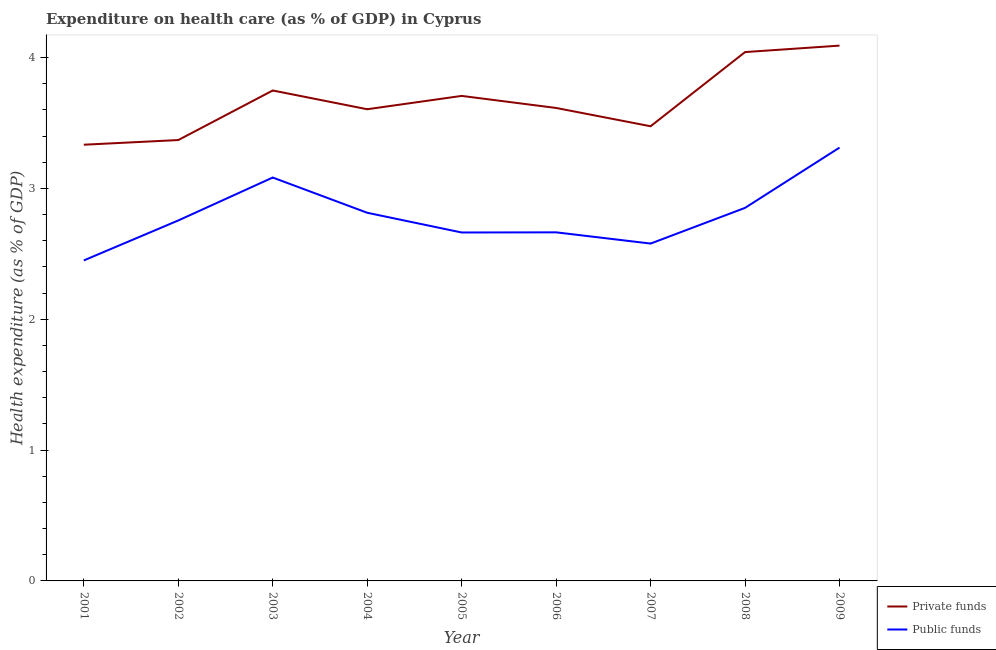Does the line corresponding to amount of public funds spent in healthcare intersect with the line corresponding to amount of private funds spent in healthcare?
Offer a terse response. No. Is the number of lines equal to the number of legend labels?
Your answer should be compact. Yes. What is the amount of private funds spent in healthcare in 2006?
Give a very brief answer. 3.61. Across all years, what is the maximum amount of private funds spent in healthcare?
Provide a short and direct response. 4.09. Across all years, what is the minimum amount of public funds spent in healthcare?
Offer a terse response. 2.45. What is the total amount of private funds spent in healthcare in the graph?
Ensure brevity in your answer.  32.98. What is the difference between the amount of private funds spent in healthcare in 2004 and that in 2006?
Your answer should be very brief. -0.01. What is the difference between the amount of private funds spent in healthcare in 2002 and the amount of public funds spent in healthcare in 2006?
Keep it short and to the point. 0.71. What is the average amount of private funds spent in healthcare per year?
Your answer should be compact. 3.66. In the year 2006, what is the difference between the amount of private funds spent in healthcare and amount of public funds spent in healthcare?
Offer a terse response. 0.95. In how many years, is the amount of public funds spent in healthcare greater than 3.2 %?
Your answer should be compact. 1. What is the ratio of the amount of public funds spent in healthcare in 2005 to that in 2009?
Keep it short and to the point. 0.8. Is the amount of private funds spent in healthcare in 2004 less than that in 2009?
Make the answer very short. Yes. What is the difference between the highest and the second highest amount of private funds spent in healthcare?
Your answer should be very brief. 0.05. What is the difference between the highest and the lowest amount of public funds spent in healthcare?
Your answer should be compact. 0.86. In how many years, is the amount of public funds spent in healthcare greater than the average amount of public funds spent in healthcare taken over all years?
Keep it short and to the point. 4. Is the sum of the amount of private funds spent in healthcare in 2001 and 2006 greater than the maximum amount of public funds spent in healthcare across all years?
Offer a terse response. Yes. Does the amount of public funds spent in healthcare monotonically increase over the years?
Give a very brief answer. No. Is the amount of public funds spent in healthcare strictly less than the amount of private funds spent in healthcare over the years?
Provide a short and direct response. Yes. What is the title of the graph?
Make the answer very short. Expenditure on health care (as % of GDP) in Cyprus. What is the label or title of the X-axis?
Provide a short and direct response. Year. What is the label or title of the Y-axis?
Make the answer very short. Health expenditure (as % of GDP). What is the Health expenditure (as % of GDP) of Private funds in 2001?
Your answer should be compact. 3.33. What is the Health expenditure (as % of GDP) in Public funds in 2001?
Provide a succinct answer. 2.45. What is the Health expenditure (as % of GDP) of Private funds in 2002?
Provide a short and direct response. 3.37. What is the Health expenditure (as % of GDP) in Public funds in 2002?
Make the answer very short. 2.75. What is the Health expenditure (as % of GDP) of Private funds in 2003?
Offer a very short reply. 3.75. What is the Health expenditure (as % of GDP) of Public funds in 2003?
Provide a short and direct response. 3.08. What is the Health expenditure (as % of GDP) in Private funds in 2004?
Your answer should be very brief. 3.6. What is the Health expenditure (as % of GDP) in Public funds in 2004?
Offer a very short reply. 2.81. What is the Health expenditure (as % of GDP) in Private funds in 2005?
Keep it short and to the point. 3.71. What is the Health expenditure (as % of GDP) of Public funds in 2005?
Your response must be concise. 2.66. What is the Health expenditure (as % of GDP) of Private funds in 2006?
Provide a short and direct response. 3.61. What is the Health expenditure (as % of GDP) in Public funds in 2006?
Your answer should be compact. 2.66. What is the Health expenditure (as % of GDP) in Private funds in 2007?
Give a very brief answer. 3.47. What is the Health expenditure (as % of GDP) of Public funds in 2007?
Ensure brevity in your answer.  2.58. What is the Health expenditure (as % of GDP) of Private funds in 2008?
Provide a succinct answer. 4.04. What is the Health expenditure (as % of GDP) in Public funds in 2008?
Offer a very short reply. 2.85. What is the Health expenditure (as % of GDP) of Private funds in 2009?
Your answer should be compact. 4.09. What is the Health expenditure (as % of GDP) in Public funds in 2009?
Offer a terse response. 3.31. Across all years, what is the maximum Health expenditure (as % of GDP) of Private funds?
Your answer should be compact. 4.09. Across all years, what is the maximum Health expenditure (as % of GDP) of Public funds?
Your response must be concise. 3.31. Across all years, what is the minimum Health expenditure (as % of GDP) in Private funds?
Provide a succinct answer. 3.33. Across all years, what is the minimum Health expenditure (as % of GDP) in Public funds?
Offer a very short reply. 2.45. What is the total Health expenditure (as % of GDP) in Private funds in the graph?
Ensure brevity in your answer.  32.98. What is the total Health expenditure (as % of GDP) of Public funds in the graph?
Provide a short and direct response. 25.17. What is the difference between the Health expenditure (as % of GDP) of Private funds in 2001 and that in 2002?
Your answer should be compact. -0.04. What is the difference between the Health expenditure (as % of GDP) in Public funds in 2001 and that in 2002?
Give a very brief answer. -0.31. What is the difference between the Health expenditure (as % of GDP) in Private funds in 2001 and that in 2003?
Provide a succinct answer. -0.41. What is the difference between the Health expenditure (as % of GDP) in Public funds in 2001 and that in 2003?
Offer a very short reply. -0.63. What is the difference between the Health expenditure (as % of GDP) in Private funds in 2001 and that in 2004?
Your answer should be compact. -0.27. What is the difference between the Health expenditure (as % of GDP) of Public funds in 2001 and that in 2004?
Offer a terse response. -0.36. What is the difference between the Health expenditure (as % of GDP) in Private funds in 2001 and that in 2005?
Provide a succinct answer. -0.37. What is the difference between the Health expenditure (as % of GDP) in Public funds in 2001 and that in 2005?
Ensure brevity in your answer.  -0.21. What is the difference between the Health expenditure (as % of GDP) of Private funds in 2001 and that in 2006?
Provide a succinct answer. -0.28. What is the difference between the Health expenditure (as % of GDP) of Public funds in 2001 and that in 2006?
Provide a succinct answer. -0.21. What is the difference between the Health expenditure (as % of GDP) in Private funds in 2001 and that in 2007?
Offer a very short reply. -0.14. What is the difference between the Health expenditure (as % of GDP) in Public funds in 2001 and that in 2007?
Ensure brevity in your answer.  -0.13. What is the difference between the Health expenditure (as % of GDP) in Private funds in 2001 and that in 2008?
Give a very brief answer. -0.71. What is the difference between the Health expenditure (as % of GDP) in Public funds in 2001 and that in 2008?
Give a very brief answer. -0.4. What is the difference between the Health expenditure (as % of GDP) of Private funds in 2001 and that in 2009?
Offer a very short reply. -0.76. What is the difference between the Health expenditure (as % of GDP) in Public funds in 2001 and that in 2009?
Your answer should be very brief. -0.86. What is the difference between the Health expenditure (as % of GDP) of Private funds in 2002 and that in 2003?
Provide a short and direct response. -0.38. What is the difference between the Health expenditure (as % of GDP) of Public funds in 2002 and that in 2003?
Your answer should be compact. -0.33. What is the difference between the Health expenditure (as % of GDP) of Private funds in 2002 and that in 2004?
Your answer should be compact. -0.24. What is the difference between the Health expenditure (as % of GDP) of Public funds in 2002 and that in 2004?
Provide a succinct answer. -0.06. What is the difference between the Health expenditure (as % of GDP) in Private funds in 2002 and that in 2005?
Make the answer very short. -0.34. What is the difference between the Health expenditure (as % of GDP) of Public funds in 2002 and that in 2005?
Your response must be concise. 0.09. What is the difference between the Health expenditure (as % of GDP) in Private funds in 2002 and that in 2006?
Offer a terse response. -0.25. What is the difference between the Health expenditure (as % of GDP) of Public funds in 2002 and that in 2006?
Keep it short and to the point. 0.09. What is the difference between the Health expenditure (as % of GDP) in Private funds in 2002 and that in 2007?
Your answer should be very brief. -0.11. What is the difference between the Health expenditure (as % of GDP) in Public funds in 2002 and that in 2007?
Keep it short and to the point. 0.18. What is the difference between the Health expenditure (as % of GDP) of Private funds in 2002 and that in 2008?
Your response must be concise. -0.67. What is the difference between the Health expenditure (as % of GDP) of Public funds in 2002 and that in 2008?
Keep it short and to the point. -0.1. What is the difference between the Health expenditure (as % of GDP) of Private funds in 2002 and that in 2009?
Provide a short and direct response. -0.72. What is the difference between the Health expenditure (as % of GDP) in Public funds in 2002 and that in 2009?
Make the answer very short. -0.56. What is the difference between the Health expenditure (as % of GDP) in Private funds in 2003 and that in 2004?
Offer a terse response. 0.14. What is the difference between the Health expenditure (as % of GDP) in Public funds in 2003 and that in 2004?
Offer a terse response. 0.27. What is the difference between the Health expenditure (as % of GDP) in Private funds in 2003 and that in 2005?
Provide a short and direct response. 0.04. What is the difference between the Health expenditure (as % of GDP) in Public funds in 2003 and that in 2005?
Provide a short and direct response. 0.42. What is the difference between the Health expenditure (as % of GDP) of Private funds in 2003 and that in 2006?
Provide a succinct answer. 0.13. What is the difference between the Health expenditure (as % of GDP) of Public funds in 2003 and that in 2006?
Give a very brief answer. 0.42. What is the difference between the Health expenditure (as % of GDP) of Private funds in 2003 and that in 2007?
Offer a terse response. 0.27. What is the difference between the Health expenditure (as % of GDP) of Public funds in 2003 and that in 2007?
Make the answer very short. 0.5. What is the difference between the Health expenditure (as % of GDP) in Private funds in 2003 and that in 2008?
Provide a succinct answer. -0.29. What is the difference between the Health expenditure (as % of GDP) of Public funds in 2003 and that in 2008?
Your answer should be very brief. 0.23. What is the difference between the Health expenditure (as % of GDP) in Private funds in 2003 and that in 2009?
Your answer should be compact. -0.34. What is the difference between the Health expenditure (as % of GDP) in Public funds in 2003 and that in 2009?
Offer a terse response. -0.23. What is the difference between the Health expenditure (as % of GDP) in Private funds in 2004 and that in 2005?
Make the answer very short. -0.1. What is the difference between the Health expenditure (as % of GDP) of Public funds in 2004 and that in 2005?
Keep it short and to the point. 0.15. What is the difference between the Health expenditure (as % of GDP) of Private funds in 2004 and that in 2006?
Keep it short and to the point. -0.01. What is the difference between the Health expenditure (as % of GDP) of Public funds in 2004 and that in 2006?
Ensure brevity in your answer.  0.15. What is the difference between the Health expenditure (as % of GDP) of Private funds in 2004 and that in 2007?
Provide a succinct answer. 0.13. What is the difference between the Health expenditure (as % of GDP) of Public funds in 2004 and that in 2007?
Provide a short and direct response. 0.24. What is the difference between the Health expenditure (as % of GDP) in Private funds in 2004 and that in 2008?
Offer a terse response. -0.44. What is the difference between the Health expenditure (as % of GDP) in Public funds in 2004 and that in 2008?
Provide a succinct answer. -0.04. What is the difference between the Health expenditure (as % of GDP) in Private funds in 2004 and that in 2009?
Make the answer very short. -0.49. What is the difference between the Health expenditure (as % of GDP) of Public funds in 2004 and that in 2009?
Offer a terse response. -0.5. What is the difference between the Health expenditure (as % of GDP) in Private funds in 2005 and that in 2006?
Your response must be concise. 0.09. What is the difference between the Health expenditure (as % of GDP) of Public funds in 2005 and that in 2006?
Provide a succinct answer. -0. What is the difference between the Health expenditure (as % of GDP) in Private funds in 2005 and that in 2007?
Ensure brevity in your answer.  0.23. What is the difference between the Health expenditure (as % of GDP) in Public funds in 2005 and that in 2007?
Your response must be concise. 0.08. What is the difference between the Health expenditure (as % of GDP) of Private funds in 2005 and that in 2008?
Your answer should be compact. -0.33. What is the difference between the Health expenditure (as % of GDP) of Public funds in 2005 and that in 2008?
Offer a very short reply. -0.19. What is the difference between the Health expenditure (as % of GDP) in Private funds in 2005 and that in 2009?
Offer a terse response. -0.38. What is the difference between the Health expenditure (as % of GDP) of Public funds in 2005 and that in 2009?
Provide a succinct answer. -0.65. What is the difference between the Health expenditure (as % of GDP) in Private funds in 2006 and that in 2007?
Your answer should be compact. 0.14. What is the difference between the Health expenditure (as % of GDP) in Public funds in 2006 and that in 2007?
Give a very brief answer. 0.09. What is the difference between the Health expenditure (as % of GDP) in Private funds in 2006 and that in 2008?
Provide a short and direct response. -0.43. What is the difference between the Health expenditure (as % of GDP) of Public funds in 2006 and that in 2008?
Ensure brevity in your answer.  -0.19. What is the difference between the Health expenditure (as % of GDP) of Private funds in 2006 and that in 2009?
Your response must be concise. -0.48. What is the difference between the Health expenditure (as % of GDP) in Public funds in 2006 and that in 2009?
Give a very brief answer. -0.65. What is the difference between the Health expenditure (as % of GDP) of Private funds in 2007 and that in 2008?
Provide a short and direct response. -0.57. What is the difference between the Health expenditure (as % of GDP) in Public funds in 2007 and that in 2008?
Your answer should be very brief. -0.27. What is the difference between the Health expenditure (as % of GDP) in Private funds in 2007 and that in 2009?
Keep it short and to the point. -0.62. What is the difference between the Health expenditure (as % of GDP) in Public funds in 2007 and that in 2009?
Keep it short and to the point. -0.73. What is the difference between the Health expenditure (as % of GDP) of Private funds in 2008 and that in 2009?
Make the answer very short. -0.05. What is the difference between the Health expenditure (as % of GDP) in Public funds in 2008 and that in 2009?
Ensure brevity in your answer.  -0.46. What is the difference between the Health expenditure (as % of GDP) in Private funds in 2001 and the Health expenditure (as % of GDP) in Public funds in 2002?
Make the answer very short. 0.58. What is the difference between the Health expenditure (as % of GDP) of Private funds in 2001 and the Health expenditure (as % of GDP) of Public funds in 2003?
Ensure brevity in your answer.  0.25. What is the difference between the Health expenditure (as % of GDP) of Private funds in 2001 and the Health expenditure (as % of GDP) of Public funds in 2004?
Give a very brief answer. 0.52. What is the difference between the Health expenditure (as % of GDP) in Private funds in 2001 and the Health expenditure (as % of GDP) in Public funds in 2005?
Your response must be concise. 0.67. What is the difference between the Health expenditure (as % of GDP) of Private funds in 2001 and the Health expenditure (as % of GDP) of Public funds in 2006?
Offer a terse response. 0.67. What is the difference between the Health expenditure (as % of GDP) of Private funds in 2001 and the Health expenditure (as % of GDP) of Public funds in 2007?
Provide a succinct answer. 0.76. What is the difference between the Health expenditure (as % of GDP) of Private funds in 2001 and the Health expenditure (as % of GDP) of Public funds in 2008?
Your answer should be very brief. 0.48. What is the difference between the Health expenditure (as % of GDP) in Private funds in 2001 and the Health expenditure (as % of GDP) in Public funds in 2009?
Provide a short and direct response. 0.02. What is the difference between the Health expenditure (as % of GDP) in Private funds in 2002 and the Health expenditure (as % of GDP) in Public funds in 2003?
Ensure brevity in your answer.  0.29. What is the difference between the Health expenditure (as % of GDP) in Private funds in 2002 and the Health expenditure (as % of GDP) in Public funds in 2004?
Give a very brief answer. 0.56. What is the difference between the Health expenditure (as % of GDP) in Private funds in 2002 and the Health expenditure (as % of GDP) in Public funds in 2005?
Keep it short and to the point. 0.71. What is the difference between the Health expenditure (as % of GDP) of Private funds in 2002 and the Health expenditure (as % of GDP) of Public funds in 2006?
Your response must be concise. 0.71. What is the difference between the Health expenditure (as % of GDP) in Private funds in 2002 and the Health expenditure (as % of GDP) in Public funds in 2007?
Make the answer very short. 0.79. What is the difference between the Health expenditure (as % of GDP) in Private funds in 2002 and the Health expenditure (as % of GDP) in Public funds in 2008?
Your answer should be compact. 0.52. What is the difference between the Health expenditure (as % of GDP) in Private funds in 2002 and the Health expenditure (as % of GDP) in Public funds in 2009?
Ensure brevity in your answer.  0.06. What is the difference between the Health expenditure (as % of GDP) in Private funds in 2003 and the Health expenditure (as % of GDP) in Public funds in 2004?
Offer a very short reply. 0.93. What is the difference between the Health expenditure (as % of GDP) in Private funds in 2003 and the Health expenditure (as % of GDP) in Public funds in 2005?
Keep it short and to the point. 1.09. What is the difference between the Health expenditure (as % of GDP) in Private funds in 2003 and the Health expenditure (as % of GDP) in Public funds in 2006?
Make the answer very short. 1.08. What is the difference between the Health expenditure (as % of GDP) of Private funds in 2003 and the Health expenditure (as % of GDP) of Public funds in 2007?
Your answer should be compact. 1.17. What is the difference between the Health expenditure (as % of GDP) in Private funds in 2003 and the Health expenditure (as % of GDP) in Public funds in 2008?
Give a very brief answer. 0.9. What is the difference between the Health expenditure (as % of GDP) of Private funds in 2003 and the Health expenditure (as % of GDP) of Public funds in 2009?
Your response must be concise. 0.44. What is the difference between the Health expenditure (as % of GDP) in Private funds in 2004 and the Health expenditure (as % of GDP) in Public funds in 2005?
Offer a very short reply. 0.94. What is the difference between the Health expenditure (as % of GDP) of Private funds in 2004 and the Health expenditure (as % of GDP) of Public funds in 2006?
Keep it short and to the point. 0.94. What is the difference between the Health expenditure (as % of GDP) of Private funds in 2004 and the Health expenditure (as % of GDP) of Public funds in 2007?
Your response must be concise. 1.03. What is the difference between the Health expenditure (as % of GDP) in Private funds in 2004 and the Health expenditure (as % of GDP) in Public funds in 2008?
Your answer should be very brief. 0.75. What is the difference between the Health expenditure (as % of GDP) of Private funds in 2004 and the Health expenditure (as % of GDP) of Public funds in 2009?
Provide a short and direct response. 0.29. What is the difference between the Health expenditure (as % of GDP) of Private funds in 2005 and the Health expenditure (as % of GDP) of Public funds in 2006?
Your answer should be compact. 1.04. What is the difference between the Health expenditure (as % of GDP) in Private funds in 2005 and the Health expenditure (as % of GDP) in Public funds in 2007?
Make the answer very short. 1.13. What is the difference between the Health expenditure (as % of GDP) in Private funds in 2005 and the Health expenditure (as % of GDP) in Public funds in 2008?
Make the answer very short. 0.86. What is the difference between the Health expenditure (as % of GDP) in Private funds in 2005 and the Health expenditure (as % of GDP) in Public funds in 2009?
Give a very brief answer. 0.39. What is the difference between the Health expenditure (as % of GDP) in Private funds in 2006 and the Health expenditure (as % of GDP) in Public funds in 2007?
Provide a short and direct response. 1.04. What is the difference between the Health expenditure (as % of GDP) in Private funds in 2006 and the Health expenditure (as % of GDP) in Public funds in 2008?
Your answer should be very brief. 0.76. What is the difference between the Health expenditure (as % of GDP) of Private funds in 2006 and the Health expenditure (as % of GDP) of Public funds in 2009?
Ensure brevity in your answer.  0.3. What is the difference between the Health expenditure (as % of GDP) in Private funds in 2007 and the Health expenditure (as % of GDP) in Public funds in 2008?
Keep it short and to the point. 0.62. What is the difference between the Health expenditure (as % of GDP) of Private funds in 2007 and the Health expenditure (as % of GDP) of Public funds in 2009?
Give a very brief answer. 0.16. What is the difference between the Health expenditure (as % of GDP) in Private funds in 2008 and the Health expenditure (as % of GDP) in Public funds in 2009?
Keep it short and to the point. 0.73. What is the average Health expenditure (as % of GDP) in Private funds per year?
Offer a very short reply. 3.66. What is the average Health expenditure (as % of GDP) of Public funds per year?
Your response must be concise. 2.8. In the year 2001, what is the difference between the Health expenditure (as % of GDP) in Private funds and Health expenditure (as % of GDP) in Public funds?
Ensure brevity in your answer.  0.88. In the year 2002, what is the difference between the Health expenditure (as % of GDP) in Private funds and Health expenditure (as % of GDP) in Public funds?
Give a very brief answer. 0.61. In the year 2003, what is the difference between the Health expenditure (as % of GDP) of Private funds and Health expenditure (as % of GDP) of Public funds?
Keep it short and to the point. 0.67. In the year 2004, what is the difference between the Health expenditure (as % of GDP) in Private funds and Health expenditure (as % of GDP) in Public funds?
Provide a succinct answer. 0.79. In the year 2005, what is the difference between the Health expenditure (as % of GDP) of Private funds and Health expenditure (as % of GDP) of Public funds?
Offer a terse response. 1.04. In the year 2006, what is the difference between the Health expenditure (as % of GDP) of Private funds and Health expenditure (as % of GDP) of Public funds?
Make the answer very short. 0.95. In the year 2007, what is the difference between the Health expenditure (as % of GDP) of Private funds and Health expenditure (as % of GDP) of Public funds?
Keep it short and to the point. 0.9. In the year 2008, what is the difference between the Health expenditure (as % of GDP) in Private funds and Health expenditure (as % of GDP) in Public funds?
Provide a succinct answer. 1.19. In the year 2009, what is the difference between the Health expenditure (as % of GDP) in Private funds and Health expenditure (as % of GDP) in Public funds?
Offer a terse response. 0.78. What is the ratio of the Health expenditure (as % of GDP) of Public funds in 2001 to that in 2002?
Offer a very short reply. 0.89. What is the ratio of the Health expenditure (as % of GDP) in Private funds in 2001 to that in 2003?
Your response must be concise. 0.89. What is the ratio of the Health expenditure (as % of GDP) in Public funds in 2001 to that in 2003?
Give a very brief answer. 0.79. What is the ratio of the Health expenditure (as % of GDP) of Private funds in 2001 to that in 2004?
Offer a terse response. 0.92. What is the ratio of the Health expenditure (as % of GDP) in Public funds in 2001 to that in 2004?
Your answer should be very brief. 0.87. What is the ratio of the Health expenditure (as % of GDP) of Private funds in 2001 to that in 2005?
Make the answer very short. 0.9. What is the ratio of the Health expenditure (as % of GDP) of Public funds in 2001 to that in 2005?
Your response must be concise. 0.92. What is the ratio of the Health expenditure (as % of GDP) of Private funds in 2001 to that in 2006?
Your answer should be compact. 0.92. What is the ratio of the Health expenditure (as % of GDP) in Public funds in 2001 to that in 2006?
Your answer should be compact. 0.92. What is the ratio of the Health expenditure (as % of GDP) in Private funds in 2001 to that in 2007?
Keep it short and to the point. 0.96. What is the ratio of the Health expenditure (as % of GDP) in Private funds in 2001 to that in 2008?
Your response must be concise. 0.82. What is the ratio of the Health expenditure (as % of GDP) of Public funds in 2001 to that in 2008?
Ensure brevity in your answer.  0.86. What is the ratio of the Health expenditure (as % of GDP) of Private funds in 2001 to that in 2009?
Your response must be concise. 0.81. What is the ratio of the Health expenditure (as % of GDP) in Public funds in 2001 to that in 2009?
Give a very brief answer. 0.74. What is the ratio of the Health expenditure (as % of GDP) of Private funds in 2002 to that in 2003?
Offer a very short reply. 0.9. What is the ratio of the Health expenditure (as % of GDP) of Public funds in 2002 to that in 2003?
Make the answer very short. 0.89. What is the ratio of the Health expenditure (as % of GDP) in Private funds in 2002 to that in 2004?
Give a very brief answer. 0.93. What is the ratio of the Health expenditure (as % of GDP) in Public funds in 2002 to that in 2004?
Offer a very short reply. 0.98. What is the ratio of the Health expenditure (as % of GDP) of Private funds in 2002 to that in 2005?
Make the answer very short. 0.91. What is the ratio of the Health expenditure (as % of GDP) in Public funds in 2002 to that in 2005?
Make the answer very short. 1.03. What is the ratio of the Health expenditure (as % of GDP) in Private funds in 2002 to that in 2006?
Give a very brief answer. 0.93. What is the ratio of the Health expenditure (as % of GDP) of Public funds in 2002 to that in 2006?
Ensure brevity in your answer.  1.03. What is the ratio of the Health expenditure (as % of GDP) of Private funds in 2002 to that in 2007?
Make the answer very short. 0.97. What is the ratio of the Health expenditure (as % of GDP) of Public funds in 2002 to that in 2007?
Keep it short and to the point. 1.07. What is the ratio of the Health expenditure (as % of GDP) of Private funds in 2002 to that in 2008?
Make the answer very short. 0.83. What is the ratio of the Health expenditure (as % of GDP) in Public funds in 2002 to that in 2008?
Give a very brief answer. 0.97. What is the ratio of the Health expenditure (as % of GDP) in Private funds in 2002 to that in 2009?
Provide a short and direct response. 0.82. What is the ratio of the Health expenditure (as % of GDP) in Public funds in 2002 to that in 2009?
Provide a short and direct response. 0.83. What is the ratio of the Health expenditure (as % of GDP) in Private funds in 2003 to that in 2004?
Your response must be concise. 1.04. What is the ratio of the Health expenditure (as % of GDP) of Public funds in 2003 to that in 2004?
Your answer should be very brief. 1.1. What is the ratio of the Health expenditure (as % of GDP) in Private funds in 2003 to that in 2005?
Your answer should be compact. 1.01. What is the ratio of the Health expenditure (as % of GDP) of Public funds in 2003 to that in 2005?
Your answer should be compact. 1.16. What is the ratio of the Health expenditure (as % of GDP) in Public funds in 2003 to that in 2006?
Keep it short and to the point. 1.16. What is the ratio of the Health expenditure (as % of GDP) in Private funds in 2003 to that in 2007?
Provide a short and direct response. 1.08. What is the ratio of the Health expenditure (as % of GDP) of Public funds in 2003 to that in 2007?
Ensure brevity in your answer.  1.2. What is the ratio of the Health expenditure (as % of GDP) in Private funds in 2003 to that in 2008?
Offer a terse response. 0.93. What is the ratio of the Health expenditure (as % of GDP) of Public funds in 2003 to that in 2008?
Provide a succinct answer. 1.08. What is the ratio of the Health expenditure (as % of GDP) in Private funds in 2003 to that in 2009?
Your answer should be compact. 0.92. What is the ratio of the Health expenditure (as % of GDP) of Public funds in 2003 to that in 2009?
Make the answer very short. 0.93. What is the ratio of the Health expenditure (as % of GDP) of Private funds in 2004 to that in 2005?
Ensure brevity in your answer.  0.97. What is the ratio of the Health expenditure (as % of GDP) in Public funds in 2004 to that in 2005?
Provide a succinct answer. 1.06. What is the ratio of the Health expenditure (as % of GDP) of Private funds in 2004 to that in 2006?
Provide a succinct answer. 1. What is the ratio of the Health expenditure (as % of GDP) in Public funds in 2004 to that in 2006?
Offer a terse response. 1.06. What is the ratio of the Health expenditure (as % of GDP) of Private funds in 2004 to that in 2007?
Ensure brevity in your answer.  1.04. What is the ratio of the Health expenditure (as % of GDP) in Public funds in 2004 to that in 2007?
Provide a short and direct response. 1.09. What is the ratio of the Health expenditure (as % of GDP) of Private funds in 2004 to that in 2008?
Provide a succinct answer. 0.89. What is the ratio of the Health expenditure (as % of GDP) of Public funds in 2004 to that in 2008?
Make the answer very short. 0.99. What is the ratio of the Health expenditure (as % of GDP) of Private funds in 2004 to that in 2009?
Make the answer very short. 0.88. What is the ratio of the Health expenditure (as % of GDP) of Public funds in 2004 to that in 2009?
Give a very brief answer. 0.85. What is the ratio of the Health expenditure (as % of GDP) of Private funds in 2005 to that in 2006?
Provide a succinct answer. 1.03. What is the ratio of the Health expenditure (as % of GDP) of Public funds in 2005 to that in 2006?
Offer a very short reply. 1. What is the ratio of the Health expenditure (as % of GDP) in Private funds in 2005 to that in 2007?
Your answer should be compact. 1.07. What is the ratio of the Health expenditure (as % of GDP) in Public funds in 2005 to that in 2007?
Your answer should be very brief. 1.03. What is the ratio of the Health expenditure (as % of GDP) of Private funds in 2005 to that in 2008?
Give a very brief answer. 0.92. What is the ratio of the Health expenditure (as % of GDP) in Public funds in 2005 to that in 2008?
Provide a succinct answer. 0.93. What is the ratio of the Health expenditure (as % of GDP) of Private funds in 2005 to that in 2009?
Provide a succinct answer. 0.91. What is the ratio of the Health expenditure (as % of GDP) of Public funds in 2005 to that in 2009?
Offer a terse response. 0.8. What is the ratio of the Health expenditure (as % of GDP) in Private funds in 2006 to that in 2007?
Offer a very short reply. 1.04. What is the ratio of the Health expenditure (as % of GDP) in Public funds in 2006 to that in 2007?
Your answer should be compact. 1.03. What is the ratio of the Health expenditure (as % of GDP) of Private funds in 2006 to that in 2008?
Ensure brevity in your answer.  0.89. What is the ratio of the Health expenditure (as % of GDP) of Public funds in 2006 to that in 2008?
Give a very brief answer. 0.93. What is the ratio of the Health expenditure (as % of GDP) of Private funds in 2006 to that in 2009?
Offer a terse response. 0.88. What is the ratio of the Health expenditure (as % of GDP) of Public funds in 2006 to that in 2009?
Keep it short and to the point. 0.8. What is the ratio of the Health expenditure (as % of GDP) in Private funds in 2007 to that in 2008?
Provide a short and direct response. 0.86. What is the ratio of the Health expenditure (as % of GDP) in Public funds in 2007 to that in 2008?
Make the answer very short. 0.9. What is the ratio of the Health expenditure (as % of GDP) of Private funds in 2007 to that in 2009?
Offer a very short reply. 0.85. What is the ratio of the Health expenditure (as % of GDP) of Public funds in 2007 to that in 2009?
Your answer should be compact. 0.78. What is the ratio of the Health expenditure (as % of GDP) in Private funds in 2008 to that in 2009?
Your answer should be very brief. 0.99. What is the ratio of the Health expenditure (as % of GDP) in Public funds in 2008 to that in 2009?
Offer a terse response. 0.86. What is the difference between the highest and the second highest Health expenditure (as % of GDP) of Private funds?
Your answer should be very brief. 0.05. What is the difference between the highest and the second highest Health expenditure (as % of GDP) of Public funds?
Make the answer very short. 0.23. What is the difference between the highest and the lowest Health expenditure (as % of GDP) of Private funds?
Ensure brevity in your answer.  0.76. What is the difference between the highest and the lowest Health expenditure (as % of GDP) in Public funds?
Keep it short and to the point. 0.86. 